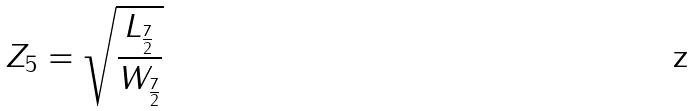<formula> <loc_0><loc_0><loc_500><loc_500>Z _ { 5 } = \sqrt { \frac { L _ { \frac { 7 } { 2 } } } { W _ { \frac { 7 } { 2 } } } }</formula> 